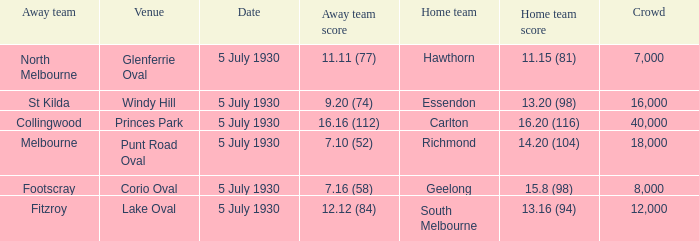What is the venue when fitzroy was the away team? Lake Oval. 